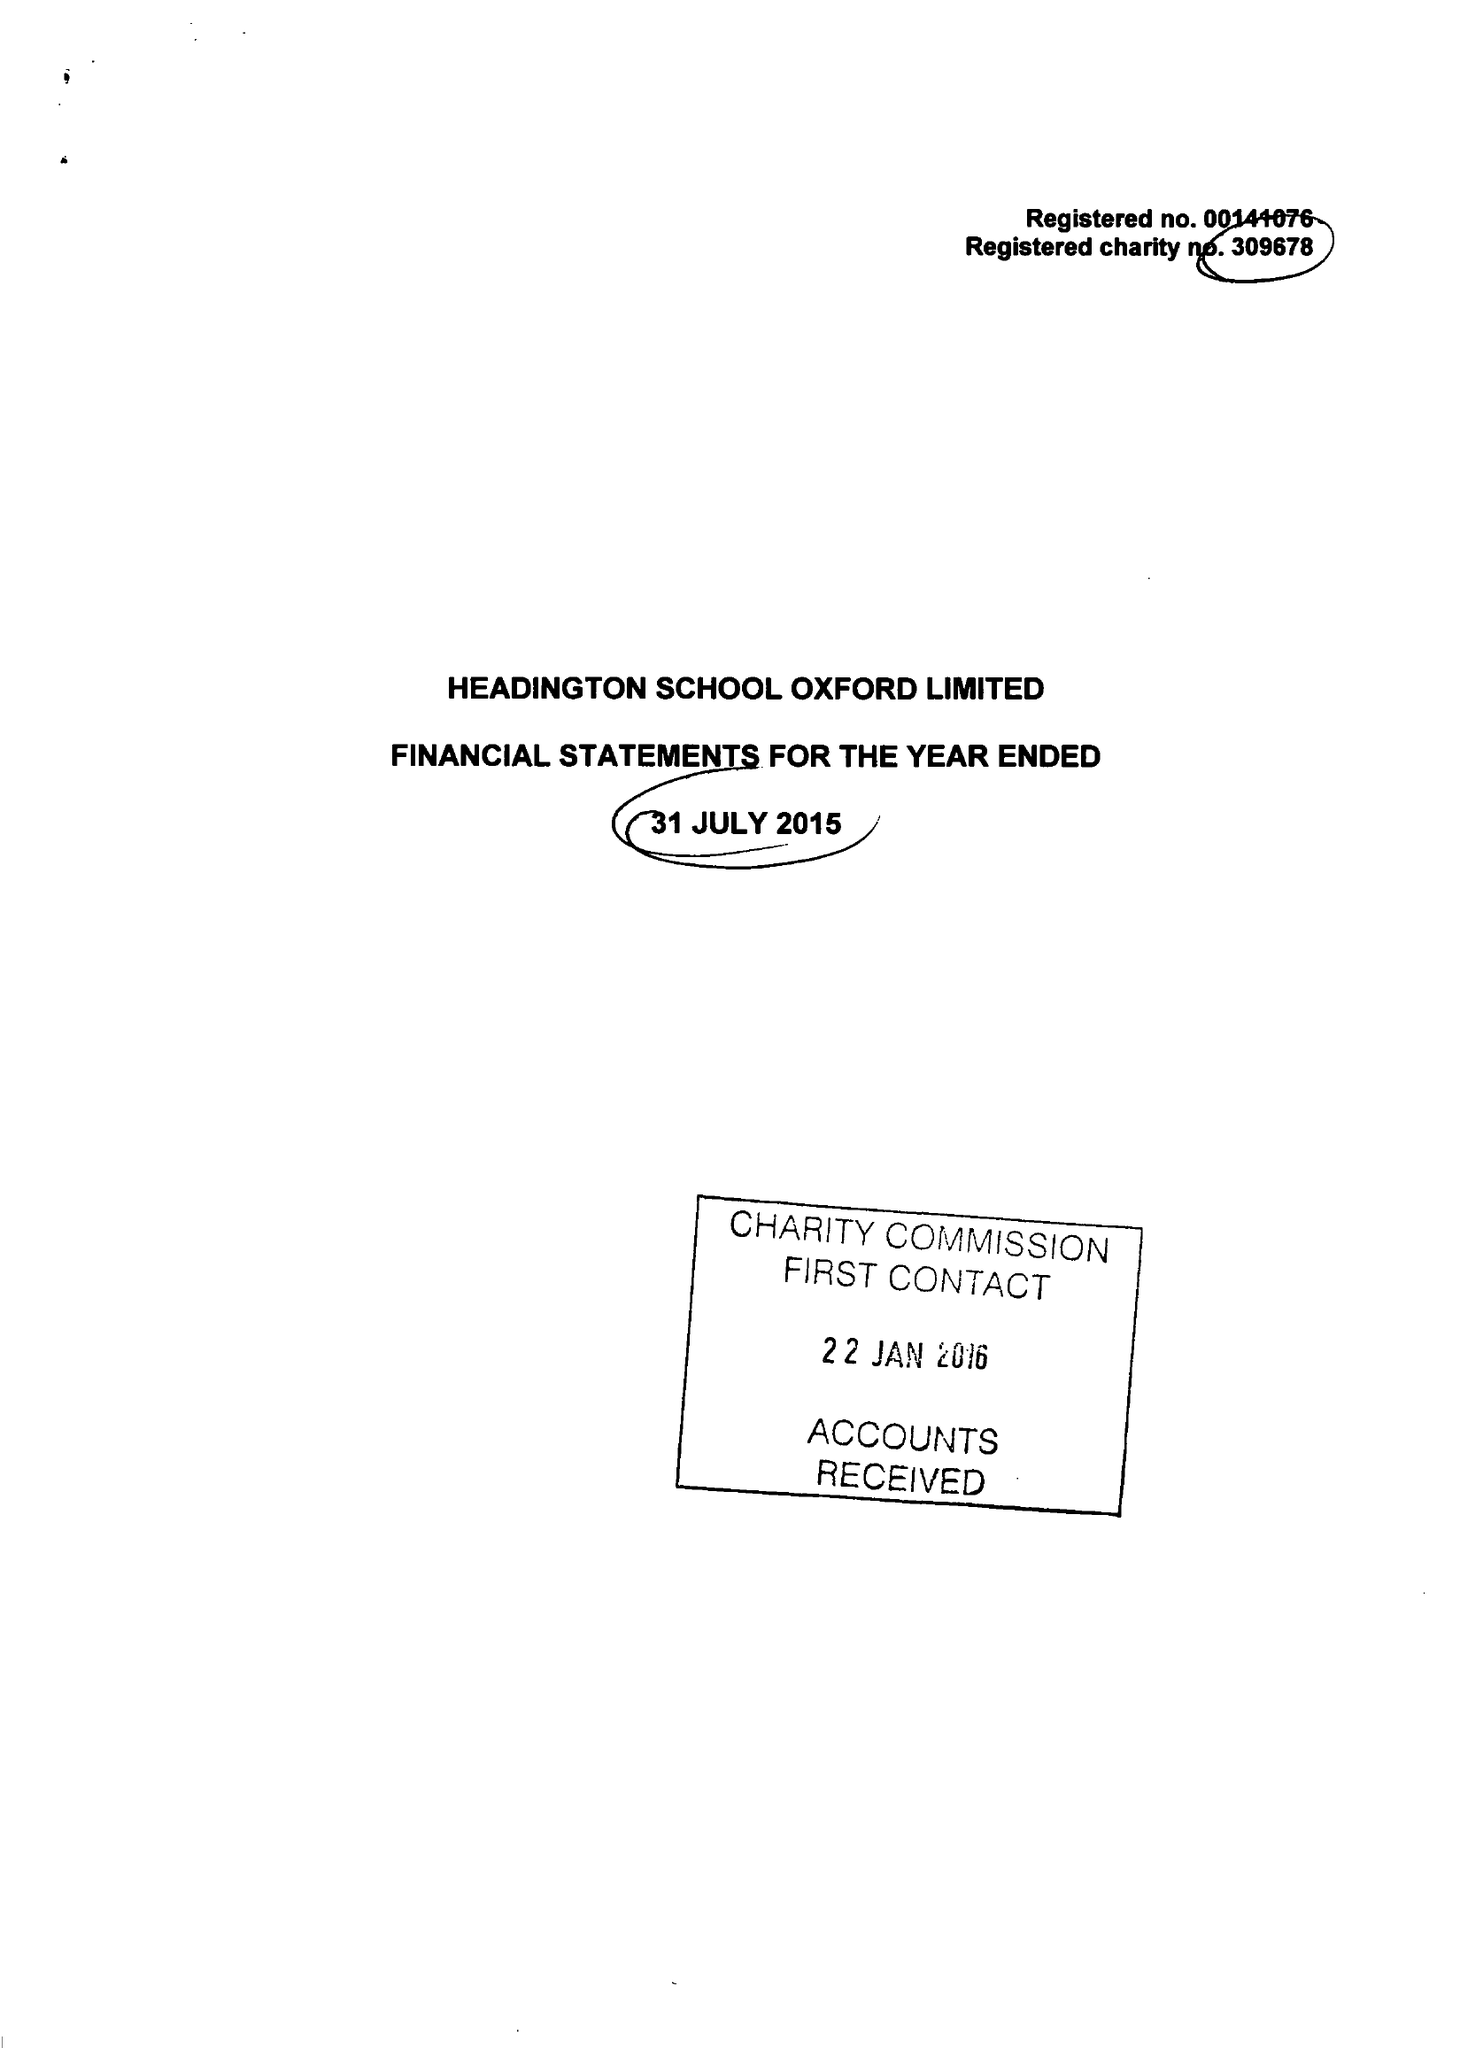What is the value for the income_annually_in_british_pounds?
Answer the question using a single word or phrase. 18786869.00 